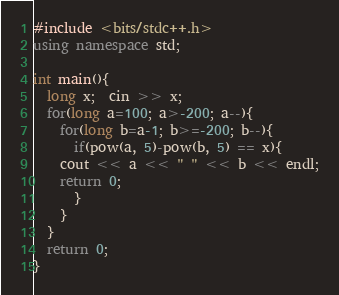<code> <loc_0><loc_0><loc_500><loc_500><_C++_>#include <bits/stdc++.h>
using namespace std;

int main(){
  long x;  cin >> x;
  for(long a=100; a>-200; a--){
    for(long b=a-1; b>=-200; b--){
      if(pow(a, 5)-pow(b, 5) == x){
	cout << a << " " << b << endl;
	return 0;
      }
    }
  }
  return 0;
}
</code> 